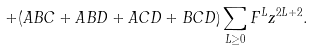Convert formula to latex. <formula><loc_0><loc_0><loc_500><loc_500>+ ( A B C + A B D + A C D + B C D ) \sum _ { L \geq 0 } F ^ { L } z ^ { 2 L + 2 } .</formula> 